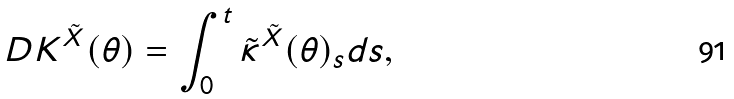<formula> <loc_0><loc_0><loc_500><loc_500>D K ^ { \tilde { X } } ( \theta ) = \int _ { 0 } ^ { t } \tilde { \kappa } ^ { \tilde { X } } ( \theta ) _ { s } d s ,</formula> 